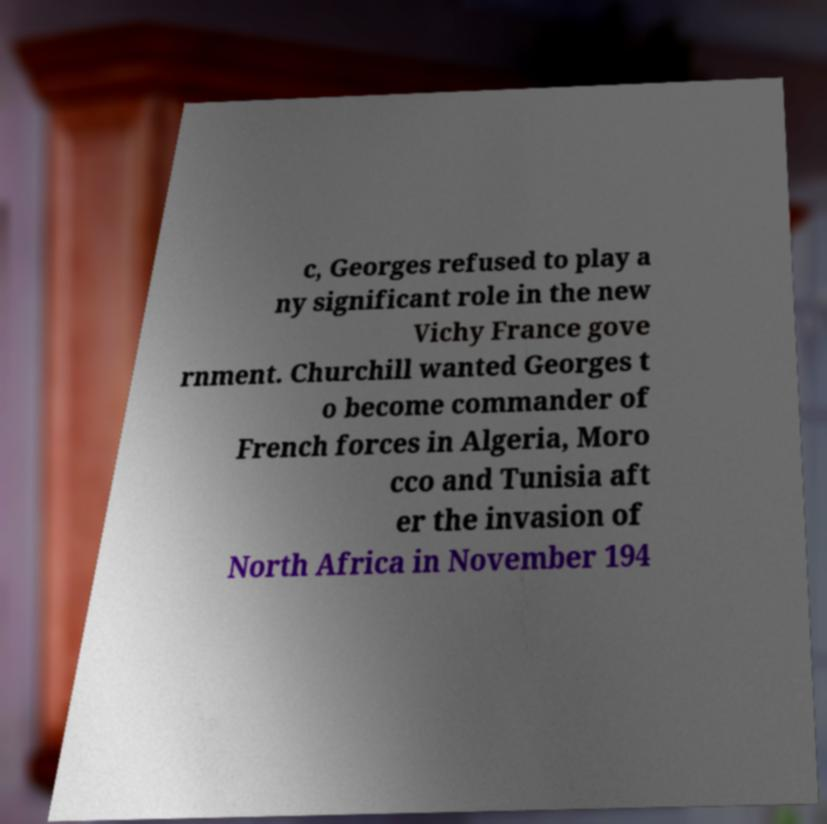Could you extract and type out the text from this image? c, Georges refused to play a ny significant role in the new Vichy France gove rnment. Churchill wanted Georges t o become commander of French forces in Algeria, Moro cco and Tunisia aft er the invasion of North Africa in November 194 